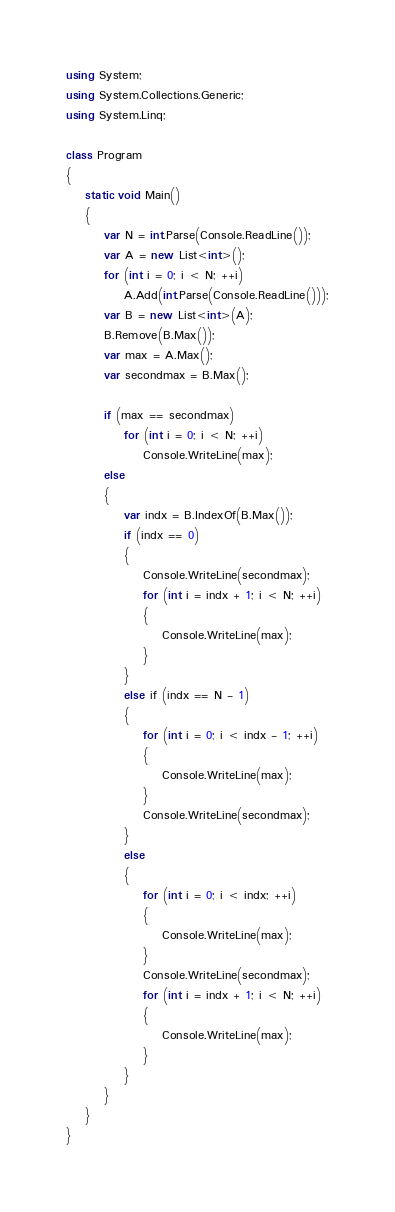Convert code to text. <code><loc_0><loc_0><loc_500><loc_500><_C#_>using System;
using System.Collections.Generic;
using System.Linq;

class Program
{
    static void Main()
    {
        var N = int.Parse(Console.ReadLine());
        var A = new List<int>();
        for (int i = 0; i < N; ++i)
            A.Add(int.Parse(Console.ReadLine()));
        var B = new List<int>(A);
        B.Remove(B.Max());
        var max = A.Max();
        var secondmax = B.Max();

        if (max == secondmax)
            for (int i = 0; i < N; ++i)
                Console.WriteLine(max);
        else
        {
            var indx = B.IndexOf(B.Max());
            if (indx == 0)
            {
                Console.WriteLine(secondmax);
                for (int i = indx + 1; i < N; ++i)
                {
                    Console.WriteLine(max);
                }
            }
            else if (indx == N - 1)
            {
                for (int i = 0; i < indx - 1; ++i)
                {
                    Console.WriteLine(max);
                }
                Console.WriteLine(secondmax);
            }
            else
            {
                for (int i = 0; i < indx; ++i)
                {
                    Console.WriteLine(max);
                }
                Console.WriteLine(secondmax);
                for (int i = indx + 1; i < N; ++i)
                {
                    Console.WriteLine(max);
                }
            }
        }
    }
}

</code> 